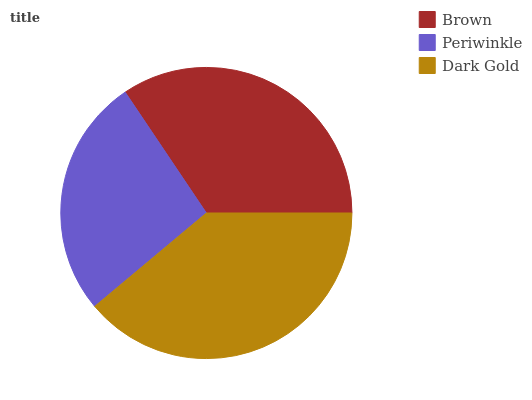Is Periwinkle the minimum?
Answer yes or no. Yes. Is Dark Gold the maximum?
Answer yes or no. Yes. Is Dark Gold the minimum?
Answer yes or no. No. Is Periwinkle the maximum?
Answer yes or no. No. Is Dark Gold greater than Periwinkle?
Answer yes or no. Yes. Is Periwinkle less than Dark Gold?
Answer yes or no. Yes. Is Periwinkle greater than Dark Gold?
Answer yes or no. No. Is Dark Gold less than Periwinkle?
Answer yes or no. No. Is Brown the high median?
Answer yes or no. Yes. Is Brown the low median?
Answer yes or no. Yes. Is Periwinkle the high median?
Answer yes or no. No. Is Dark Gold the low median?
Answer yes or no. No. 